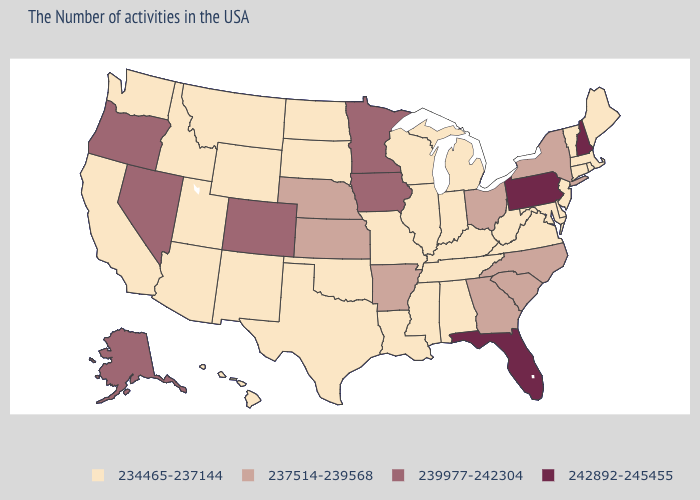What is the value of Massachusetts?
Concise answer only. 234465-237144. What is the lowest value in the West?
Give a very brief answer. 234465-237144. How many symbols are there in the legend?
Write a very short answer. 4. Name the states that have a value in the range 234465-237144?
Write a very short answer. Maine, Massachusetts, Rhode Island, Vermont, Connecticut, New Jersey, Delaware, Maryland, Virginia, West Virginia, Michigan, Kentucky, Indiana, Alabama, Tennessee, Wisconsin, Illinois, Mississippi, Louisiana, Missouri, Oklahoma, Texas, South Dakota, North Dakota, Wyoming, New Mexico, Utah, Montana, Arizona, Idaho, California, Washington, Hawaii. What is the value of Arizona?
Quick response, please. 234465-237144. Does Ohio have the same value as Nebraska?
Be succinct. Yes. Does Nebraska have the lowest value in the USA?
Concise answer only. No. What is the highest value in the USA?
Be succinct. 242892-245455. Does Utah have the lowest value in the USA?
Answer briefly. Yes. Name the states that have a value in the range 239977-242304?
Keep it brief. Minnesota, Iowa, Colorado, Nevada, Oregon, Alaska. Does Ohio have the highest value in the MidWest?
Give a very brief answer. No. What is the lowest value in states that border Washington?
Give a very brief answer. 234465-237144. What is the highest value in the South ?
Write a very short answer. 242892-245455. What is the lowest value in the USA?
Quick response, please. 234465-237144. 